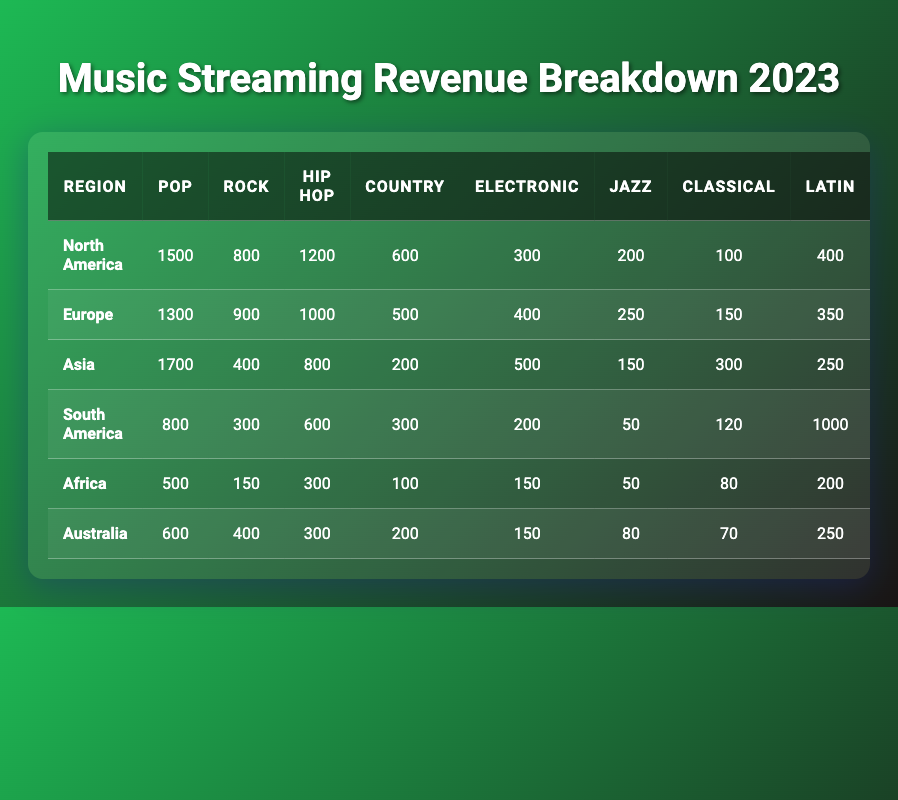What is the total revenue for North America? The table shows the total revenue for each region in the last column. For North America, the value listed is 4100.
Answer: 4100 Which genre generates the highest revenue in Asia? Looking at the genre revenues for Asia, Pop has the highest value at 1700 compared to other genres.
Answer: Pop What is the combined revenue of Hip Hop and R&B genres in Europe? The table shows Hip Hop revenue in Europe as 1000 and there is no R&B category listed. Hence, the combined revenue for Hip Hop is simply 1000.
Answer: 1000 Is the total revenue for Africa less than 2000? The total revenue for Africa is listed as 1530, which is indeed less than 2000.
Answer: Yes Which region has the highest revenue from the Latin genre? By checking the Latin genre revenue, South America has the highest revenue of 1000 compared to other regions listed.
Answer: South America What is the average revenue generated from the Rock genre across all regions? The total revenue from Rock across the regions is 800 (NA) + 900 (EU) + 400 (Asia) + 300 (SA) + 150 (AF) + 400 (AU) = 3000. Since there are 6 regions, the average revenue is 3000 / 6 = 500.
Answer: 500 What is the difference in Pop genre revenue between Asia and Africa? Asia's Pop revenue is 1700, while Africa's is 500. The difference is calculated as 1700 - 500 = 1200.
Answer: 1200 Which region generates a total revenue of 3600? The table shows that South America has a total revenue of 3600.
Answer: South America Calculate the total revenue for all regions combined. The total revenue can be calculated by summing the total revenue of each region: 4100 (NA) + 4100 (EU) + 4100 (Asia) + 3600 (SA) + 1530 (AF) + 2050 (AU) = 20580.
Answer: 20580 In which genre does Europe perform better than North America? Comparing the genre revenues, Europe performs better than North America in Rock (900 vs 800), and Jazz (250 vs 200).
Answer: Rock and Jazz 